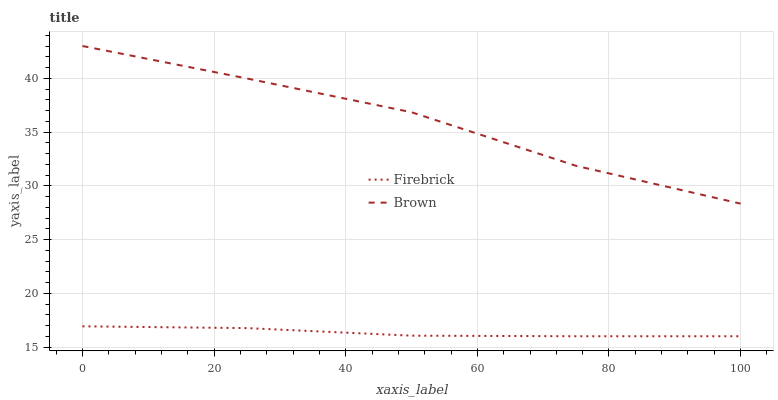Does Firebrick have the minimum area under the curve?
Answer yes or no. Yes. Does Brown have the maximum area under the curve?
Answer yes or no. Yes. Does Firebrick have the maximum area under the curve?
Answer yes or no. No. Is Firebrick the smoothest?
Answer yes or no. Yes. Is Brown the roughest?
Answer yes or no. Yes. Is Firebrick the roughest?
Answer yes or no. No. Does Firebrick have the highest value?
Answer yes or no. No. Is Firebrick less than Brown?
Answer yes or no. Yes. Is Brown greater than Firebrick?
Answer yes or no. Yes. Does Firebrick intersect Brown?
Answer yes or no. No. 